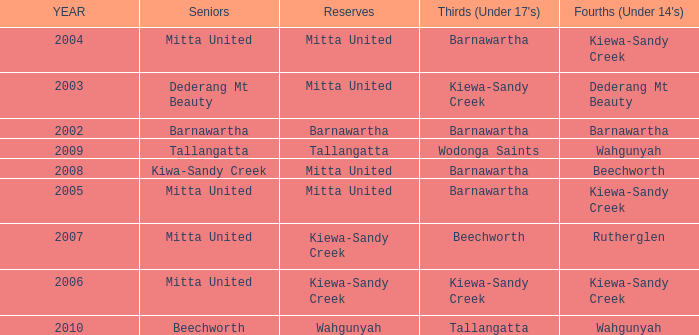Which Thirds (Under 17's) have a Reserve of barnawartha? Barnawartha. 